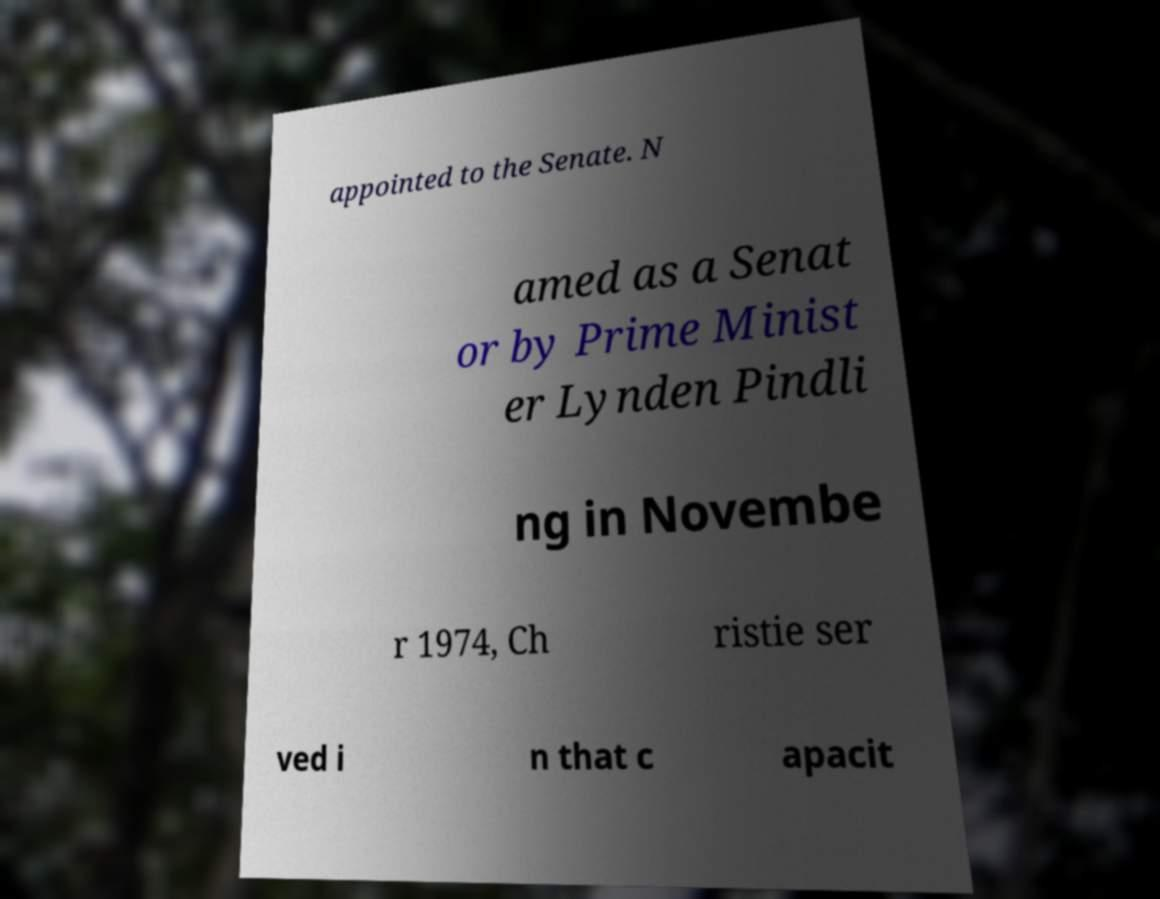Can you accurately transcribe the text from the provided image for me? appointed to the Senate. N amed as a Senat or by Prime Minist er Lynden Pindli ng in Novembe r 1974, Ch ristie ser ved i n that c apacit 